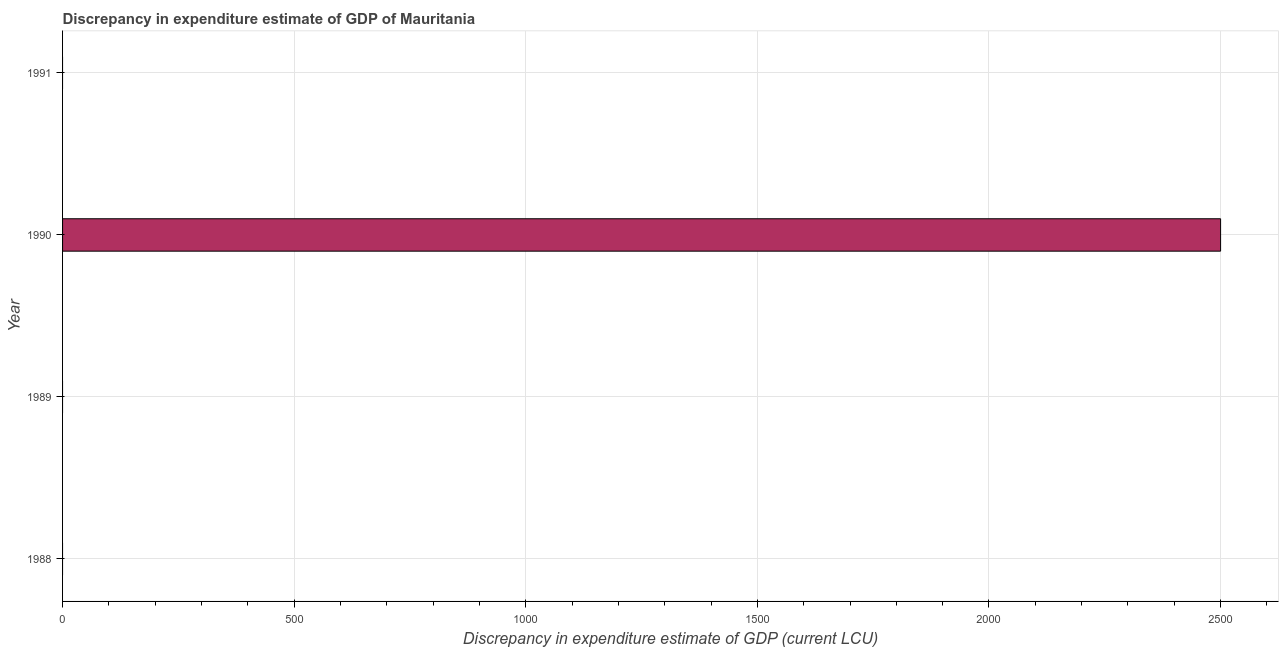Does the graph contain any zero values?
Offer a very short reply. Yes. Does the graph contain grids?
Make the answer very short. Yes. What is the title of the graph?
Ensure brevity in your answer.  Discrepancy in expenditure estimate of GDP of Mauritania. What is the label or title of the X-axis?
Offer a terse response. Discrepancy in expenditure estimate of GDP (current LCU). What is the label or title of the Y-axis?
Make the answer very short. Year. What is the discrepancy in expenditure estimate of gdp in 1990?
Keep it short and to the point. 2500. Across all years, what is the maximum discrepancy in expenditure estimate of gdp?
Offer a terse response. 2500. Across all years, what is the minimum discrepancy in expenditure estimate of gdp?
Provide a succinct answer. 0. What is the sum of the discrepancy in expenditure estimate of gdp?
Provide a short and direct response. 2500. What is the average discrepancy in expenditure estimate of gdp per year?
Offer a terse response. 625. What is the median discrepancy in expenditure estimate of gdp?
Ensure brevity in your answer.  0. In how many years, is the discrepancy in expenditure estimate of gdp greater than 2200 LCU?
Your response must be concise. 1. What is the difference between the highest and the lowest discrepancy in expenditure estimate of gdp?
Make the answer very short. 2500. What is the difference between two consecutive major ticks on the X-axis?
Your answer should be very brief. 500. Are the values on the major ticks of X-axis written in scientific E-notation?
Provide a succinct answer. No. What is the Discrepancy in expenditure estimate of GDP (current LCU) of 1988?
Your answer should be very brief. 0. What is the Discrepancy in expenditure estimate of GDP (current LCU) in 1989?
Keep it short and to the point. 0. What is the Discrepancy in expenditure estimate of GDP (current LCU) in 1990?
Your response must be concise. 2500. What is the Discrepancy in expenditure estimate of GDP (current LCU) of 1991?
Make the answer very short. 0. 